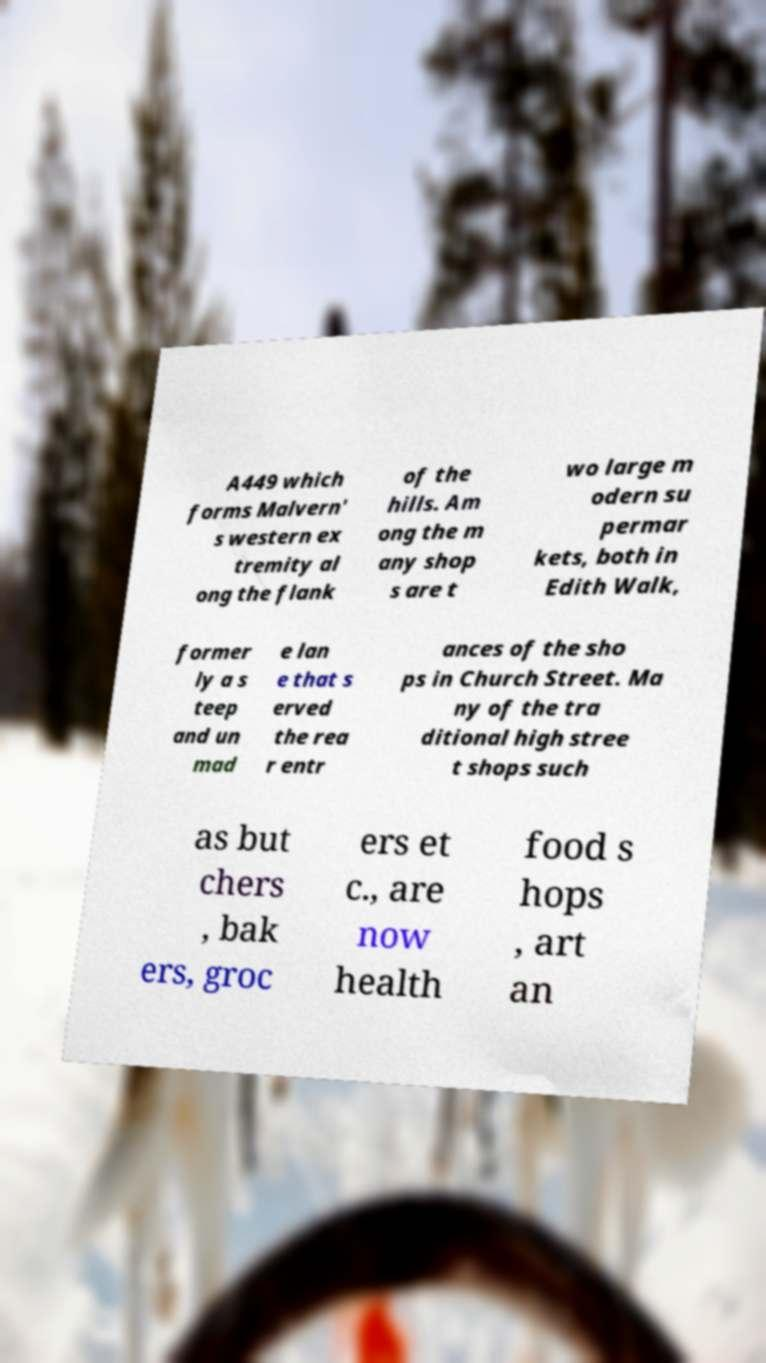What messages or text are displayed in this image? I need them in a readable, typed format. A449 which forms Malvern' s western ex tremity al ong the flank of the hills. Am ong the m any shop s are t wo large m odern su permar kets, both in Edith Walk, former ly a s teep and un mad e lan e that s erved the rea r entr ances of the sho ps in Church Street. Ma ny of the tra ditional high stree t shops such as but chers , bak ers, groc ers et c., are now health food s hops , art an 